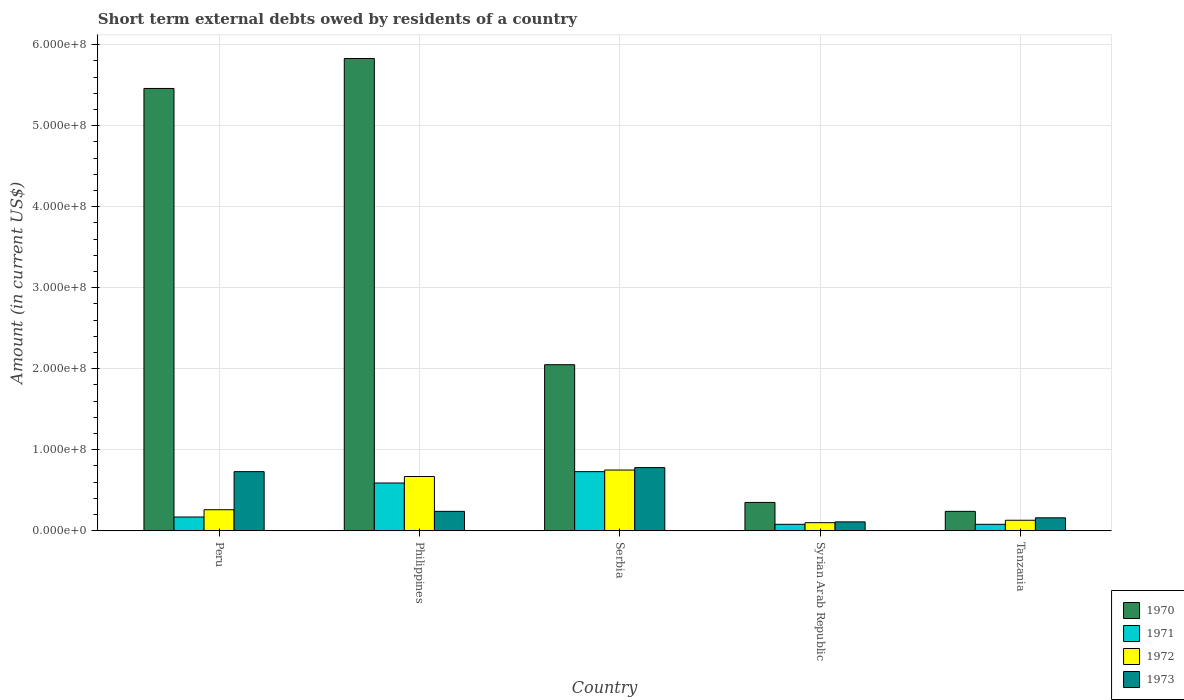How many groups of bars are there?
Offer a terse response. 5. How many bars are there on the 4th tick from the left?
Keep it short and to the point. 4. How many bars are there on the 5th tick from the right?
Your response must be concise. 4. What is the label of the 3rd group of bars from the left?
Your answer should be compact. Serbia. In how many cases, is the number of bars for a given country not equal to the number of legend labels?
Your answer should be compact. 0. What is the amount of short-term external debts owed by residents in 1973 in Serbia?
Your answer should be compact. 7.80e+07. Across all countries, what is the maximum amount of short-term external debts owed by residents in 1973?
Offer a terse response. 7.80e+07. Across all countries, what is the minimum amount of short-term external debts owed by residents in 1972?
Keep it short and to the point. 1.00e+07. In which country was the amount of short-term external debts owed by residents in 1971 maximum?
Make the answer very short. Serbia. In which country was the amount of short-term external debts owed by residents in 1971 minimum?
Provide a short and direct response. Syrian Arab Republic. What is the total amount of short-term external debts owed by residents in 1972 in the graph?
Your answer should be very brief. 1.91e+08. What is the difference between the amount of short-term external debts owed by residents in 1972 in Peru and that in Tanzania?
Ensure brevity in your answer.  1.30e+07. What is the difference between the amount of short-term external debts owed by residents in 1971 in Philippines and the amount of short-term external debts owed by residents in 1972 in Tanzania?
Make the answer very short. 4.60e+07. What is the average amount of short-term external debts owed by residents in 1973 per country?
Provide a succinct answer. 4.04e+07. What is the difference between the amount of short-term external debts owed by residents of/in 1970 and amount of short-term external debts owed by residents of/in 1972 in Syrian Arab Republic?
Your answer should be very brief. 2.50e+07. In how many countries, is the amount of short-term external debts owed by residents in 1972 greater than 300000000 US$?
Make the answer very short. 0. What is the ratio of the amount of short-term external debts owed by residents in 1973 in Peru to that in Syrian Arab Republic?
Your answer should be very brief. 6.64. Is the difference between the amount of short-term external debts owed by residents in 1970 in Philippines and Tanzania greater than the difference between the amount of short-term external debts owed by residents in 1972 in Philippines and Tanzania?
Give a very brief answer. Yes. What is the difference between the highest and the second highest amount of short-term external debts owed by residents in 1973?
Make the answer very short. 5.40e+07. What is the difference between the highest and the lowest amount of short-term external debts owed by residents in 1970?
Your answer should be compact. 5.59e+08. In how many countries, is the amount of short-term external debts owed by residents in 1973 greater than the average amount of short-term external debts owed by residents in 1973 taken over all countries?
Make the answer very short. 2. Is it the case that in every country, the sum of the amount of short-term external debts owed by residents in 1972 and amount of short-term external debts owed by residents in 1970 is greater than the sum of amount of short-term external debts owed by residents in 1971 and amount of short-term external debts owed by residents in 1973?
Your answer should be compact. No. What does the 4th bar from the left in Serbia represents?
Keep it short and to the point. 1973. Is it the case that in every country, the sum of the amount of short-term external debts owed by residents in 1972 and amount of short-term external debts owed by residents in 1973 is greater than the amount of short-term external debts owed by residents in 1970?
Give a very brief answer. No. What is the difference between two consecutive major ticks on the Y-axis?
Your answer should be very brief. 1.00e+08. Does the graph contain any zero values?
Provide a short and direct response. No. What is the title of the graph?
Offer a terse response. Short term external debts owed by residents of a country. Does "1965" appear as one of the legend labels in the graph?
Your response must be concise. No. What is the label or title of the X-axis?
Your answer should be compact. Country. What is the Amount (in current US$) of 1970 in Peru?
Make the answer very short. 5.46e+08. What is the Amount (in current US$) in 1971 in Peru?
Your response must be concise. 1.70e+07. What is the Amount (in current US$) in 1972 in Peru?
Offer a terse response. 2.60e+07. What is the Amount (in current US$) in 1973 in Peru?
Make the answer very short. 7.30e+07. What is the Amount (in current US$) in 1970 in Philippines?
Your answer should be compact. 5.83e+08. What is the Amount (in current US$) of 1971 in Philippines?
Offer a terse response. 5.90e+07. What is the Amount (in current US$) of 1972 in Philippines?
Offer a terse response. 6.70e+07. What is the Amount (in current US$) of 1973 in Philippines?
Provide a succinct answer. 2.40e+07. What is the Amount (in current US$) in 1970 in Serbia?
Make the answer very short. 2.05e+08. What is the Amount (in current US$) in 1971 in Serbia?
Offer a very short reply. 7.30e+07. What is the Amount (in current US$) of 1972 in Serbia?
Keep it short and to the point. 7.50e+07. What is the Amount (in current US$) in 1973 in Serbia?
Your answer should be compact. 7.80e+07. What is the Amount (in current US$) of 1970 in Syrian Arab Republic?
Offer a terse response. 3.50e+07. What is the Amount (in current US$) of 1972 in Syrian Arab Republic?
Provide a short and direct response. 1.00e+07. What is the Amount (in current US$) in 1973 in Syrian Arab Republic?
Your response must be concise. 1.10e+07. What is the Amount (in current US$) in 1970 in Tanzania?
Your answer should be compact. 2.40e+07. What is the Amount (in current US$) of 1972 in Tanzania?
Make the answer very short. 1.30e+07. What is the Amount (in current US$) of 1973 in Tanzania?
Your answer should be very brief. 1.60e+07. Across all countries, what is the maximum Amount (in current US$) in 1970?
Your response must be concise. 5.83e+08. Across all countries, what is the maximum Amount (in current US$) of 1971?
Your response must be concise. 7.30e+07. Across all countries, what is the maximum Amount (in current US$) of 1972?
Provide a short and direct response. 7.50e+07. Across all countries, what is the maximum Amount (in current US$) of 1973?
Offer a very short reply. 7.80e+07. Across all countries, what is the minimum Amount (in current US$) in 1970?
Your response must be concise. 2.40e+07. Across all countries, what is the minimum Amount (in current US$) of 1972?
Offer a terse response. 1.00e+07. Across all countries, what is the minimum Amount (in current US$) of 1973?
Keep it short and to the point. 1.10e+07. What is the total Amount (in current US$) in 1970 in the graph?
Your answer should be compact. 1.39e+09. What is the total Amount (in current US$) in 1971 in the graph?
Offer a terse response. 1.65e+08. What is the total Amount (in current US$) of 1972 in the graph?
Keep it short and to the point. 1.91e+08. What is the total Amount (in current US$) of 1973 in the graph?
Your answer should be compact. 2.02e+08. What is the difference between the Amount (in current US$) in 1970 in Peru and that in Philippines?
Your answer should be compact. -3.70e+07. What is the difference between the Amount (in current US$) in 1971 in Peru and that in Philippines?
Offer a terse response. -4.20e+07. What is the difference between the Amount (in current US$) of 1972 in Peru and that in Philippines?
Provide a succinct answer. -4.10e+07. What is the difference between the Amount (in current US$) in 1973 in Peru and that in Philippines?
Give a very brief answer. 4.90e+07. What is the difference between the Amount (in current US$) in 1970 in Peru and that in Serbia?
Provide a succinct answer. 3.41e+08. What is the difference between the Amount (in current US$) in 1971 in Peru and that in Serbia?
Your answer should be very brief. -5.60e+07. What is the difference between the Amount (in current US$) in 1972 in Peru and that in Serbia?
Make the answer very short. -4.90e+07. What is the difference between the Amount (in current US$) in 1973 in Peru and that in Serbia?
Provide a short and direct response. -5.00e+06. What is the difference between the Amount (in current US$) of 1970 in Peru and that in Syrian Arab Republic?
Keep it short and to the point. 5.11e+08. What is the difference between the Amount (in current US$) of 1971 in Peru and that in Syrian Arab Republic?
Your answer should be compact. 9.00e+06. What is the difference between the Amount (in current US$) of 1972 in Peru and that in Syrian Arab Republic?
Make the answer very short. 1.60e+07. What is the difference between the Amount (in current US$) of 1973 in Peru and that in Syrian Arab Republic?
Give a very brief answer. 6.20e+07. What is the difference between the Amount (in current US$) in 1970 in Peru and that in Tanzania?
Provide a succinct answer. 5.22e+08. What is the difference between the Amount (in current US$) of 1971 in Peru and that in Tanzania?
Provide a succinct answer. 9.00e+06. What is the difference between the Amount (in current US$) in 1972 in Peru and that in Tanzania?
Your answer should be compact. 1.30e+07. What is the difference between the Amount (in current US$) in 1973 in Peru and that in Tanzania?
Your answer should be compact. 5.70e+07. What is the difference between the Amount (in current US$) of 1970 in Philippines and that in Serbia?
Give a very brief answer. 3.78e+08. What is the difference between the Amount (in current US$) in 1971 in Philippines and that in Serbia?
Ensure brevity in your answer.  -1.40e+07. What is the difference between the Amount (in current US$) of 1972 in Philippines and that in Serbia?
Provide a succinct answer. -8.00e+06. What is the difference between the Amount (in current US$) in 1973 in Philippines and that in Serbia?
Ensure brevity in your answer.  -5.40e+07. What is the difference between the Amount (in current US$) in 1970 in Philippines and that in Syrian Arab Republic?
Offer a very short reply. 5.48e+08. What is the difference between the Amount (in current US$) in 1971 in Philippines and that in Syrian Arab Republic?
Keep it short and to the point. 5.10e+07. What is the difference between the Amount (in current US$) in 1972 in Philippines and that in Syrian Arab Republic?
Provide a succinct answer. 5.70e+07. What is the difference between the Amount (in current US$) in 1973 in Philippines and that in Syrian Arab Republic?
Make the answer very short. 1.30e+07. What is the difference between the Amount (in current US$) in 1970 in Philippines and that in Tanzania?
Give a very brief answer. 5.59e+08. What is the difference between the Amount (in current US$) in 1971 in Philippines and that in Tanzania?
Your response must be concise. 5.10e+07. What is the difference between the Amount (in current US$) in 1972 in Philippines and that in Tanzania?
Make the answer very short. 5.40e+07. What is the difference between the Amount (in current US$) of 1970 in Serbia and that in Syrian Arab Republic?
Ensure brevity in your answer.  1.70e+08. What is the difference between the Amount (in current US$) of 1971 in Serbia and that in Syrian Arab Republic?
Provide a succinct answer. 6.50e+07. What is the difference between the Amount (in current US$) of 1972 in Serbia and that in Syrian Arab Republic?
Give a very brief answer. 6.50e+07. What is the difference between the Amount (in current US$) in 1973 in Serbia and that in Syrian Arab Republic?
Offer a terse response. 6.70e+07. What is the difference between the Amount (in current US$) of 1970 in Serbia and that in Tanzania?
Make the answer very short. 1.81e+08. What is the difference between the Amount (in current US$) of 1971 in Serbia and that in Tanzania?
Your response must be concise. 6.50e+07. What is the difference between the Amount (in current US$) of 1972 in Serbia and that in Tanzania?
Your response must be concise. 6.20e+07. What is the difference between the Amount (in current US$) in 1973 in Serbia and that in Tanzania?
Your answer should be compact. 6.20e+07. What is the difference between the Amount (in current US$) of 1970 in Syrian Arab Republic and that in Tanzania?
Offer a very short reply. 1.10e+07. What is the difference between the Amount (in current US$) in 1971 in Syrian Arab Republic and that in Tanzania?
Keep it short and to the point. 0. What is the difference between the Amount (in current US$) of 1973 in Syrian Arab Republic and that in Tanzania?
Provide a succinct answer. -5.00e+06. What is the difference between the Amount (in current US$) of 1970 in Peru and the Amount (in current US$) of 1971 in Philippines?
Ensure brevity in your answer.  4.87e+08. What is the difference between the Amount (in current US$) of 1970 in Peru and the Amount (in current US$) of 1972 in Philippines?
Provide a short and direct response. 4.79e+08. What is the difference between the Amount (in current US$) of 1970 in Peru and the Amount (in current US$) of 1973 in Philippines?
Your answer should be very brief. 5.22e+08. What is the difference between the Amount (in current US$) of 1971 in Peru and the Amount (in current US$) of 1972 in Philippines?
Offer a very short reply. -5.00e+07. What is the difference between the Amount (in current US$) in 1971 in Peru and the Amount (in current US$) in 1973 in Philippines?
Your response must be concise. -7.00e+06. What is the difference between the Amount (in current US$) of 1972 in Peru and the Amount (in current US$) of 1973 in Philippines?
Provide a succinct answer. 2.00e+06. What is the difference between the Amount (in current US$) of 1970 in Peru and the Amount (in current US$) of 1971 in Serbia?
Your answer should be very brief. 4.73e+08. What is the difference between the Amount (in current US$) of 1970 in Peru and the Amount (in current US$) of 1972 in Serbia?
Make the answer very short. 4.71e+08. What is the difference between the Amount (in current US$) in 1970 in Peru and the Amount (in current US$) in 1973 in Serbia?
Keep it short and to the point. 4.68e+08. What is the difference between the Amount (in current US$) of 1971 in Peru and the Amount (in current US$) of 1972 in Serbia?
Your response must be concise. -5.80e+07. What is the difference between the Amount (in current US$) of 1971 in Peru and the Amount (in current US$) of 1973 in Serbia?
Your response must be concise. -6.10e+07. What is the difference between the Amount (in current US$) of 1972 in Peru and the Amount (in current US$) of 1973 in Serbia?
Your response must be concise. -5.20e+07. What is the difference between the Amount (in current US$) of 1970 in Peru and the Amount (in current US$) of 1971 in Syrian Arab Republic?
Your answer should be compact. 5.38e+08. What is the difference between the Amount (in current US$) in 1970 in Peru and the Amount (in current US$) in 1972 in Syrian Arab Republic?
Offer a terse response. 5.36e+08. What is the difference between the Amount (in current US$) in 1970 in Peru and the Amount (in current US$) in 1973 in Syrian Arab Republic?
Your answer should be compact. 5.35e+08. What is the difference between the Amount (in current US$) of 1971 in Peru and the Amount (in current US$) of 1973 in Syrian Arab Republic?
Give a very brief answer. 6.00e+06. What is the difference between the Amount (in current US$) of 1972 in Peru and the Amount (in current US$) of 1973 in Syrian Arab Republic?
Provide a succinct answer. 1.50e+07. What is the difference between the Amount (in current US$) of 1970 in Peru and the Amount (in current US$) of 1971 in Tanzania?
Make the answer very short. 5.38e+08. What is the difference between the Amount (in current US$) of 1970 in Peru and the Amount (in current US$) of 1972 in Tanzania?
Provide a succinct answer. 5.33e+08. What is the difference between the Amount (in current US$) of 1970 in Peru and the Amount (in current US$) of 1973 in Tanzania?
Ensure brevity in your answer.  5.30e+08. What is the difference between the Amount (in current US$) of 1971 in Peru and the Amount (in current US$) of 1972 in Tanzania?
Give a very brief answer. 4.00e+06. What is the difference between the Amount (in current US$) of 1972 in Peru and the Amount (in current US$) of 1973 in Tanzania?
Keep it short and to the point. 1.00e+07. What is the difference between the Amount (in current US$) in 1970 in Philippines and the Amount (in current US$) in 1971 in Serbia?
Provide a short and direct response. 5.10e+08. What is the difference between the Amount (in current US$) in 1970 in Philippines and the Amount (in current US$) in 1972 in Serbia?
Keep it short and to the point. 5.08e+08. What is the difference between the Amount (in current US$) of 1970 in Philippines and the Amount (in current US$) of 1973 in Serbia?
Offer a terse response. 5.05e+08. What is the difference between the Amount (in current US$) in 1971 in Philippines and the Amount (in current US$) in 1972 in Serbia?
Provide a succinct answer. -1.60e+07. What is the difference between the Amount (in current US$) of 1971 in Philippines and the Amount (in current US$) of 1973 in Serbia?
Your response must be concise. -1.90e+07. What is the difference between the Amount (in current US$) in 1972 in Philippines and the Amount (in current US$) in 1973 in Serbia?
Keep it short and to the point. -1.10e+07. What is the difference between the Amount (in current US$) of 1970 in Philippines and the Amount (in current US$) of 1971 in Syrian Arab Republic?
Give a very brief answer. 5.75e+08. What is the difference between the Amount (in current US$) in 1970 in Philippines and the Amount (in current US$) in 1972 in Syrian Arab Republic?
Your answer should be very brief. 5.73e+08. What is the difference between the Amount (in current US$) of 1970 in Philippines and the Amount (in current US$) of 1973 in Syrian Arab Republic?
Provide a succinct answer. 5.72e+08. What is the difference between the Amount (in current US$) of 1971 in Philippines and the Amount (in current US$) of 1972 in Syrian Arab Republic?
Offer a very short reply. 4.90e+07. What is the difference between the Amount (in current US$) in 1971 in Philippines and the Amount (in current US$) in 1973 in Syrian Arab Republic?
Keep it short and to the point. 4.80e+07. What is the difference between the Amount (in current US$) in 1972 in Philippines and the Amount (in current US$) in 1973 in Syrian Arab Republic?
Keep it short and to the point. 5.60e+07. What is the difference between the Amount (in current US$) of 1970 in Philippines and the Amount (in current US$) of 1971 in Tanzania?
Your answer should be very brief. 5.75e+08. What is the difference between the Amount (in current US$) in 1970 in Philippines and the Amount (in current US$) in 1972 in Tanzania?
Provide a short and direct response. 5.70e+08. What is the difference between the Amount (in current US$) in 1970 in Philippines and the Amount (in current US$) in 1973 in Tanzania?
Ensure brevity in your answer.  5.67e+08. What is the difference between the Amount (in current US$) in 1971 in Philippines and the Amount (in current US$) in 1972 in Tanzania?
Ensure brevity in your answer.  4.60e+07. What is the difference between the Amount (in current US$) in 1971 in Philippines and the Amount (in current US$) in 1973 in Tanzania?
Your answer should be very brief. 4.30e+07. What is the difference between the Amount (in current US$) of 1972 in Philippines and the Amount (in current US$) of 1973 in Tanzania?
Your answer should be very brief. 5.10e+07. What is the difference between the Amount (in current US$) of 1970 in Serbia and the Amount (in current US$) of 1971 in Syrian Arab Republic?
Provide a succinct answer. 1.97e+08. What is the difference between the Amount (in current US$) in 1970 in Serbia and the Amount (in current US$) in 1972 in Syrian Arab Republic?
Offer a terse response. 1.95e+08. What is the difference between the Amount (in current US$) in 1970 in Serbia and the Amount (in current US$) in 1973 in Syrian Arab Republic?
Give a very brief answer. 1.94e+08. What is the difference between the Amount (in current US$) in 1971 in Serbia and the Amount (in current US$) in 1972 in Syrian Arab Republic?
Your answer should be compact. 6.30e+07. What is the difference between the Amount (in current US$) in 1971 in Serbia and the Amount (in current US$) in 1973 in Syrian Arab Republic?
Your answer should be very brief. 6.20e+07. What is the difference between the Amount (in current US$) in 1972 in Serbia and the Amount (in current US$) in 1973 in Syrian Arab Republic?
Offer a very short reply. 6.40e+07. What is the difference between the Amount (in current US$) in 1970 in Serbia and the Amount (in current US$) in 1971 in Tanzania?
Ensure brevity in your answer.  1.97e+08. What is the difference between the Amount (in current US$) of 1970 in Serbia and the Amount (in current US$) of 1972 in Tanzania?
Keep it short and to the point. 1.92e+08. What is the difference between the Amount (in current US$) in 1970 in Serbia and the Amount (in current US$) in 1973 in Tanzania?
Make the answer very short. 1.89e+08. What is the difference between the Amount (in current US$) of 1971 in Serbia and the Amount (in current US$) of 1972 in Tanzania?
Offer a very short reply. 6.00e+07. What is the difference between the Amount (in current US$) of 1971 in Serbia and the Amount (in current US$) of 1973 in Tanzania?
Ensure brevity in your answer.  5.70e+07. What is the difference between the Amount (in current US$) in 1972 in Serbia and the Amount (in current US$) in 1973 in Tanzania?
Provide a short and direct response. 5.90e+07. What is the difference between the Amount (in current US$) in 1970 in Syrian Arab Republic and the Amount (in current US$) in 1971 in Tanzania?
Your answer should be very brief. 2.70e+07. What is the difference between the Amount (in current US$) of 1970 in Syrian Arab Republic and the Amount (in current US$) of 1972 in Tanzania?
Provide a succinct answer. 2.20e+07. What is the difference between the Amount (in current US$) in 1970 in Syrian Arab Republic and the Amount (in current US$) in 1973 in Tanzania?
Offer a terse response. 1.90e+07. What is the difference between the Amount (in current US$) of 1971 in Syrian Arab Republic and the Amount (in current US$) of 1972 in Tanzania?
Offer a very short reply. -5.00e+06. What is the difference between the Amount (in current US$) in 1971 in Syrian Arab Republic and the Amount (in current US$) in 1973 in Tanzania?
Make the answer very short. -8.00e+06. What is the difference between the Amount (in current US$) in 1972 in Syrian Arab Republic and the Amount (in current US$) in 1973 in Tanzania?
Your answer should be compact. -6.00e+06. What is the average Amount (in current US$) of 1970 per country?
Give a very brief answer. 2.79e+08. What is the average Amount (in current US$) of 1971 per country?
Provide a succinct answer. 3.30e+07. What is the average Amount (in current US$) in 1972 per country?
Your response must be concise. 3.82e+07. What is the average Amount (in current US$) of 1973 per country?
Offer a terse response. 4.04e+07. What is the difference between the Amount (in current US$) in 1970 and Amount (in current US$) in 1971 in Peru?
Offer a very short reply. 5.29e+08. What is the difference between the Amount (in current US$) of 1970 and Amount (in current US$) of 1972 in Peru?
Give a very brief answer. 5.20e+08. What is the difference between the Amount (in current US$) in 1970 and Amount (in current US$) in 1973 in Peru?
Ensure brevity in your answer.  4.73e+08. What is the difference between the Amount (in current US$) in 1971 and Amount (in current US$) in 1972 in Peru?
Your answer should be compact. -9.00e+06. What is the difference between the Amount (in current US$) of 1971 and Amount (in current US$) of 1973 in Peru?
Offer a very short reply. -5.60e+07. What is the difference between the Amount (in current US$) of 1972 and Amount (in current US$) of 1973 in Peru?
Offer a very short reply. -4.70e+07. What is the difference between the Amount (in current US$) in 1970 and Amount (in current US$) in 1971 in Philippines?
Your response must be concise. 5.24e+08. What is the difference between the Amount (in current US$) in 1970 and Amount (in current US$) in 1972 in Philippines?
Your answer should be very brief. 5.16e+08. What is the difference between the Amount (in current US$) in 1970 and Amount (in current US$) in 1973 in Philippines?
Your response must be concise. 5.59e+08. What is the difference between the Amount (in current US$) in 1971 and Amount (in current US$) in 1972 in Philippines?
Keep it short and to the point. -8.00e+06. What is the difference between the Amount (in current US$) of 1971 and Amount (in current US$) of 1973 in Philippines?
Provide a succinct answer. 3.50e+07. What is the difference between the Amount (in current US$) in 1972 and Amount (in current US$) in 1973 in Philippines?
Ensure brevity in your answer.  4.30e+07. What is the difference between the Amount (in current US$) of 1970 and Amount (in current US$) of 1971 in Serbia?
Your answer should be compact. 1.32e+08. What is the difference between the Amount (in current US$) of 1970 and Amount (in current US$) of 1972 in Serbia?
Offer a very short reply. 1.30e+08. What is the difference between the Amount (in current US$) of 1970 and Amount (in current US$) of 1973 in Serbia?
Make the answer very short. 1.27e+08. What is the difference between the Amount (in current US$) in 1971 and Amount (in current US$) in 1973 in Serbia?
Offer a terse response. -5.00e+06. What is the difference between the Amount (in current US$) of 1970 and Amount (in current US$) of 1971 in Syrian Arab Republic?
Your answer should be compact. 2.70e+07. What is the difference between the Amount (in current US$) in 1970 and Amount (in current US$) in 1972 in Syrian Arab Republic?
Give a very brief answer. 2.50e+07. What is the difference between the Amount (in current US$) of 1970 and Amount (in current US$) of 1973 in Syrian Arab Republic?
Keep it short and to the point. 2.40e+07. What is the difference between the Amount (in current US$) in 1971 and Amount (in current US$) in 1972 in Syrian Arab Republic?
Offer a terse response. -2.00e+06. What is the difference between the Amount (in current US$) of 1971 and Amount (in current US$) of 1973 in Syrian Arab Republic?
Your answer should be very brief. -3.00e+06. What is the difference between the Amount (in current US$) in 1970 and Amount (in current US$) in 1971 in Tanzania?
Ensure brevity in your answer.  1.60e+07. What is the difference between the Amount (in current US$) in 1970 and Amount (in current US$) in 1972 in Tanzania?
Offer a terse response. 1.10e+07. What is the difference between the Amount (in current US$) of 1971 and Amount (in current US$) of 1972 in Tanzania?
Your response must be concise. -5.00e+06. What is the difference between the Amount (in current US$) of 1971 and Amount (in current US$) of 1973 in Tanzania?
Offer a terse response. -8.00e+06. What is the difference between the Amount (in current US$) in 1972 and Amount (in current US$) in 1973 in Tanzania?
Your answer should be compact. -3.00e+06. What is the ratio of the Amount (in current US$) of 1970 in Peru to that in Philippines?
Make the answer very short. 0.94. What is the ratio of the Amount (in current US$) in 1971 in Peru to that in Philippines?
Your answer should be very brief. 0.29. What is the ratio of the Amount (in current US$) of 1972 in Peru to that in Philippines?
Your answer should be compact. 0.39. What is the ratio of the Amount (in current US$) in 1973 in Peru to that in Philippines?
Give a very brief answer. 3.04. What is the ratio of the Amount (in current US$) in 1970 in Peru to that in Serbia?
Give a very brief answer. 2.66. What is the ratio of the Amount (in current US$) in 1971 in Peru to that in Serbia?
Your answer should be very brief. 0.23. What is the ratio of the Amount (in current US$) of 1972 in Peru to that in Serbia?
Ensure brevity in your answer.  0.35. What is the ratio of the Amount (in current US$) of 1973 in Peru to that in Serbia?
Your answer should be very brief. 0.94. What is the ratio of the Amount (in current US$) in 1971 in Peru to that in Syrian Arab Republic?
Provide a succinct answer. 2.12. What is the ratio of the Amount (in current US$) in 1972 in Peru to that in Syrian Arab Republic?
Provide a short and direct response. 2.6. What is the ratio of the Amount (in current US$) in 1973 in Peru to that in Syrian Arab Republic?
Ensure brevity in your answer.  6.64. What is the ratio of the Amount (in current US$) of 1970 in Peru to that in Tanzania?
Ensure brevity in your answer.  22.75. What is the ratio of the Amount (in current US$) of 1971 in Peru to that in Tanzania?
Your response must be concise. 2.12. What is the ratio of the Amount (in current US$) of 1972 in Peru to that in Tanzania?
Offer a terse response. 2. What is the ratio of the Amount (in current US$) of 1973 in Peru to that in Tanzania?
Offer a very short reply. 4.56. What is the ratio of the Amount (in current US$) in 1970 in Philippines to that in Serbia?
Ensure brevity in your answer.  2.84. What is the ratio of the Amount (in current US$) of 1971 in Philippines to that in Serbia?
Offer a terse response. 0.81. What is the ratio of the Amount (in current US$) in 1972 in Philippines to that in Serbia?
Your answer should be compact. 0.89. What is the ratio of the Amount (in current US$) of 1973 in Philippines to that in Serbia?
Your answer should be compact. 0.31. What is the ratio of the Amount (in current US$) in 1970 in Philippines to that in Syrian Arab Republic?
Your answer should be compact. 16.66. What is the ratio of the Amount (in current US$) in 1971 in Philippines to that in Syrian Arab Republic?
Keep it short and to the point. 7.38. What is the ratio of the Amount (in current US$) in 1973 in Philippines to that in Syrian Arab Republic?
Ensure brevity in your answer.  2.18. What is the ratio of the Amount (in current US$) in 1970 in Philippines to that in Tanzania?
Provide a succinct answer. 24.29. What is the ratio of the Amount (in current US$) of 1971 in Philippines to that in Tanzania?
Offer a very short reply. 7.38. What is the ratio of the Amount (in current US$) of 1972 in Philippines to that in Tanzania?
Provide a succinct answer. 5.15. What is the ratio of the Amount (in current US$) in 1973 in Philippines to that in Tanzania?
Offer a very short reply. 1.5. What is the ratio of the Amount (in current US$) in 1970 in Serbia to that in Syrian Arab Republic?
Your response must be concise. 5.86. What is the ratio of the Amount (in current US$) in 1971 in Serbia to that in Syrian Arab Republic?
Offer a terse response. 9.12. What is the ratio of the Amount (in current US$) of 1972 in Serbia to that in Syrian Arab Republic?
Ensure brevity in your answer.  7.5. What is the ratio of the Amount (in current US$) of 1973 in Serbia to that in Syrian Arab Republic?
Provide a succinct answer. 7.09. What is the ratio of the Amount (in current US$) in 1970 in Serbia to that in Tanzania?
Keep it short and to the point. 8.54. What is the ratio of the Amount (in current US$) of 1971 in Serbia to that in Tanzania?
Your answer should be very brief. 9.12. What is the ratio of the Amount (in current US$) of 1972 in Serbia to that in Tanzania?
Give a very brief answer. 5.77. What is the ratio of the Amount (in current US$) in 1973 in Serbia to that in Tanzania?
Give a very brief answer. 4.88. What is the ratio of the Amount (in current US$) of 1970 in Syrian Arab Republic to that in Tanzania?
Make the answer very short. 1.46. What is the ratio of the Amount (in current US$) of 1972 in Syrian Arab Republic to that in Tanzania?
Offer a very short reply. 0.77. What is the ratio of the Amount (in current US$) in 1973 in Syrian Arab Republic to that in Tanzania?
Provide a short and direct response. 0.69. What is the difference between the highest and the second highest Amount (in current US$) in 1970?
Your answer should be compact. 3.70e+07. What is the difference between the highest and the second highest Amount (in current US$) of 1971?
Your answer should be compact. 1.40e+07. What is the difference between the highest and the lowest Amount (in current US$) of 1970?
Your response must be concise. 5.59e+08. What is the difference between the highest and the lowest Amount (in current US$) of 1971?
Your response must be concise. 6.50e+07. What is the difference between the highest and the lowest Amount (in current US$) of 1972?
Give a very brief answer. 6.50e+07. What is the difference between the highest and the lowest Amount (in current US$) of 1973?
Ensure brevity in your answer.  6.70e+07. 